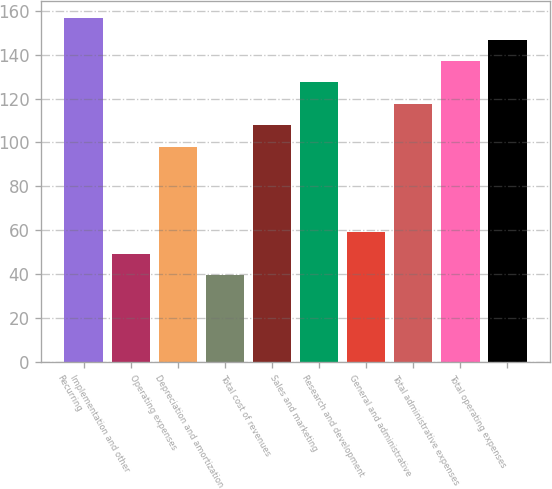Convert chart to OTSL. <chart><loc_0><loc_0><loc_500><loc_500><bar_chart><fcel>Recurring<fcel>Implementation and other<fcel>Operating expenses<fcel>Depreciation and amortization<fcel>Total cost of revenues<fcel>Sales and marketing<fcel>Research and development<fcel>General and administrative<fcel>Total administrative expenses<fcel>Total operating expenses<nl><fcel>156.6<fcel>49.35<fcel>98.1<fcel>39.6<fcel>107.85<fcel>127.35<fcel>59.1<fcel>117.6<fcel>137.1<fcel>146.85<nl></chart> 